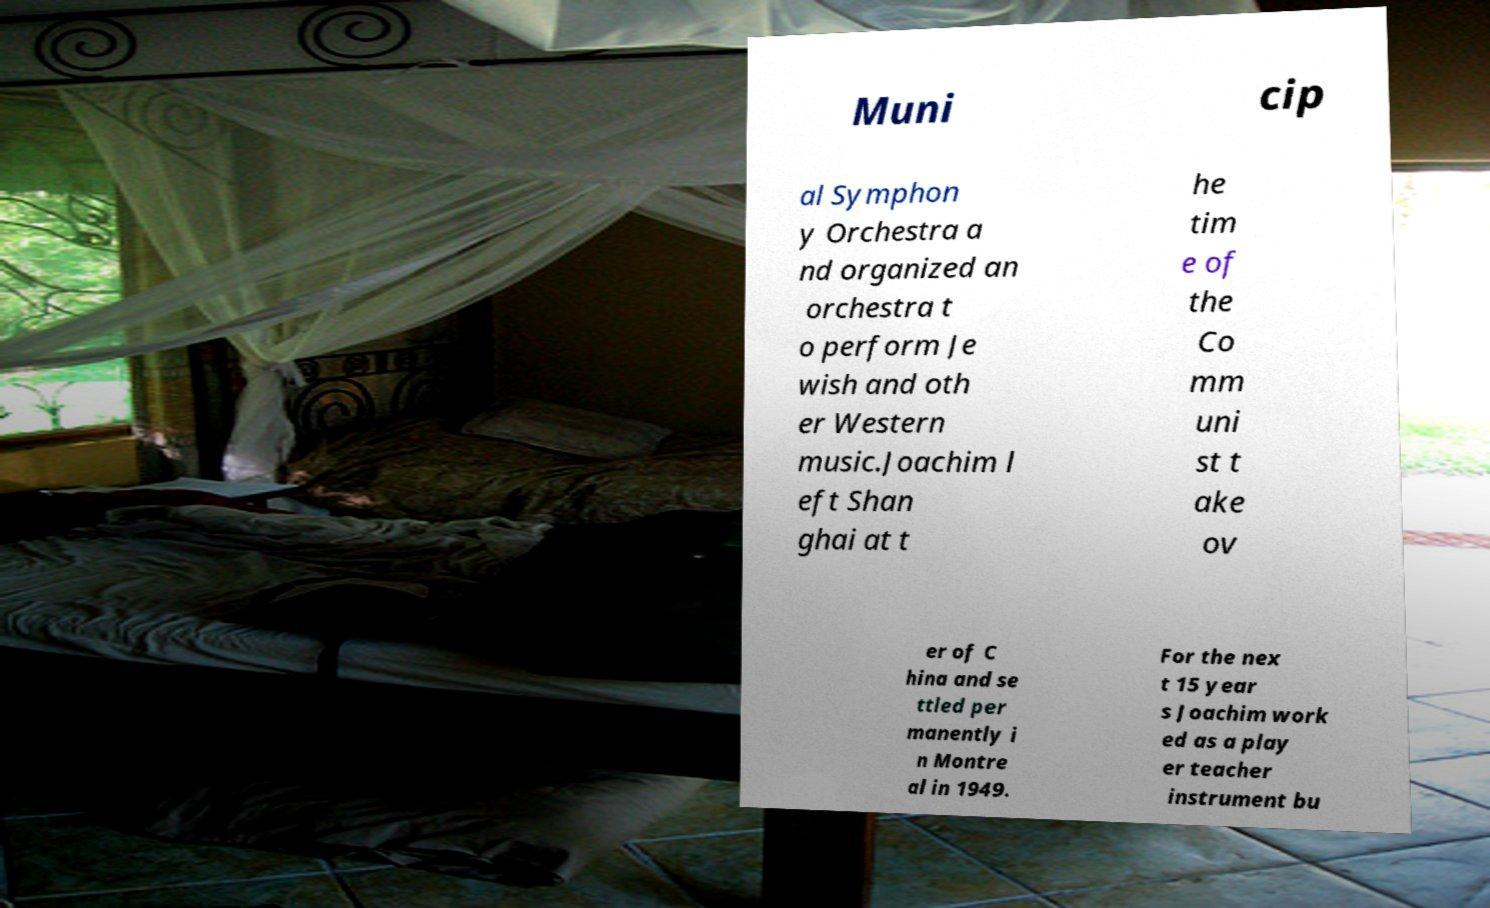Can you accurately transcribe the text from the provided image for me? Muni cip al Symphon y Orchestra a nd organized an orchestra t o perform Je wish and oth er Western music.Joachim l eft Shan ghai at t he tim e of the Co mm uni st t ake ov er of C hina and se ttled per manently i n Montre al in 1949. For the nex t 15 year s Joachim work ed as a play er teacher instrument bu 